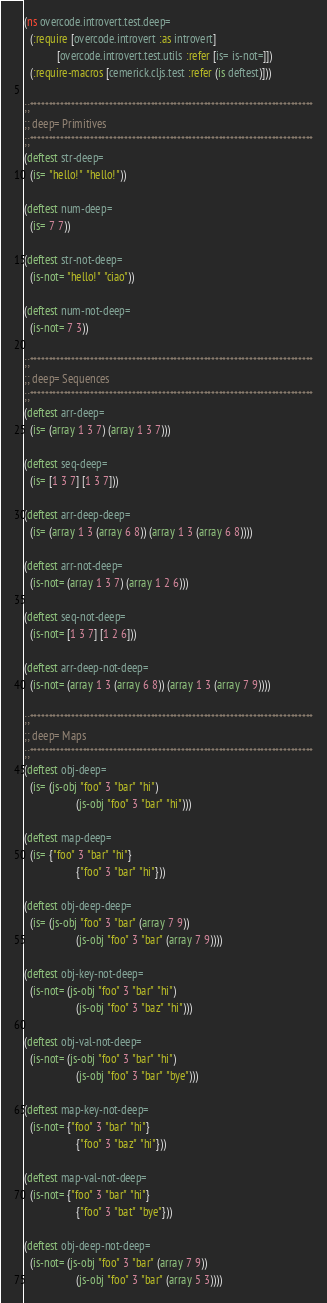<code> <loc_0><loc_0><loc_500><loc_500><_Clojure_>(ns overcode.introvert.test.deep=
  (:require [overcode.introvert :as introvert]
            [overcode.introvert.test.utils :refer [is= is-not=]])
  (:require-macros [cemerick.cljs.test :refer (is deftest)]))

;;***************************************************************************
;; deep= Primitives
;;***************************************************************************
(deftest str-deep=
  (is= "hello!" "hello!"))

(deftest num-deep=
  (is= 7 7))

(deftest str-not-deep=
  (is-not= "hello!" "ciao"))

(deftest num-not-deep=
  (is-not= 7 3))

;;***************************************************************************
;; deep= Sequences
;;***************************************************************************
(deftest arr-deep=
  (is= (array 1 3 7) (array 1 3 7)))

(deftest seq-deep=
  (is= [1 3 7] [1 3 7]))

(deftest arr-deep-deep=
  (is= (array 1 3 (array 6 8)) (array 1 3 (array 6 8))))

(deftest arr-not-deep=
  (is-not= (array 1 3 7) (array 1 2 6)))

(deftest seq-not-deep=
  (is-not= [1 3 7] [1 2 6]))

(deftest arr-deep-not-deep=
  (is-not= (array 1 3 (array 6 8)) (array 1 3 (array 7 9))))

;;***************************************************************************
;; deep= Maps
;;***************************************************************************
(deftest obj-deep=
  (is= (js-obj "foo" 3 "bar" "hi")
                   (js-obj "foo" 3 "bar" "hi")))

(deftest map-deep=
  (is= {"foo" 3 "bar" "hi"}
                   {"foo" 3 "bar" "hi"}))

(deftest obj-deep-deep=
  (is= (js-obj "foo" 3 "bar" (array 7 9))
                   (js-obj "foo" 3 "bar" (array 7 9))))

(deftest obj-key-not-deep=
  (is-not= (js-obj "foo" 3 "bar" "hi")
                   (js-obj "foo" 3 "baz" "hi")))

(deftest obj-val-not-deep=
  (is-not= (js-obj "foo" 3 "bar" "hi")
                   (js-obj "foo" 3 "bar" "bye")))

(deftest map-key-not-deep=
  (is-not= {"foo" 3 "bar" "hi"}
                   {"foo" 3 "baz" "hi"}))

(deftest map-val-not-deep=
  (is-not= {"foo" 3 "bar" "hi"}
                   {"foo" 3 "bat" "bye"}))

(deftest obj-deep-not-deep=
  (is-not= (js-obj "foo" 3 "bar" (array 7 9))
                   (js-obj "foo" 3 "bar" (array 5 3))))
</code> 